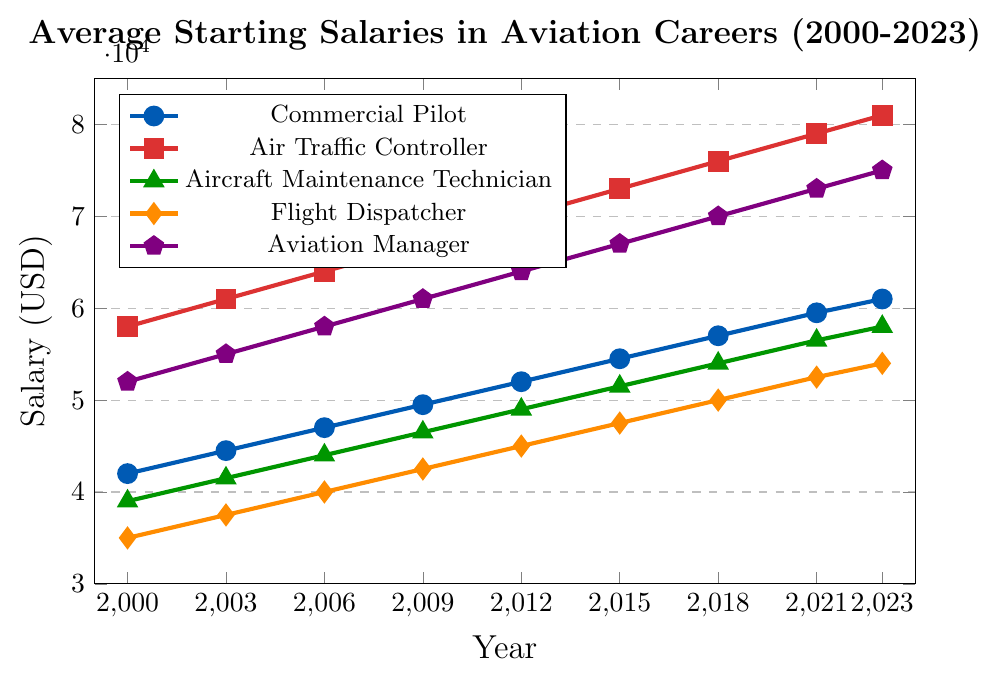What's the highest starting salary in 2023 and for which career? According to the chart, the highest starting salary in 2023 is represented by the highest point on the y-axis. The Air Traffic Controller line (shown in red) reaches $81,000, which is the highest value on the plot.
Answer: $81,000 for Air Traffic Controller What's the trend of the starting salary for Aircraft Maintenance Technicians from 2000 to 2023? The line for Aircraft Maintenance Technicians (in green) shows a steady upward trend from $39,000 in 2000 to $58,000 in 2023, indicating continuous growth over the years.
Answer: Steady upward trend from $39,000 to $58,000 In which year did the Commercial Pilot's salary surpass $50,000? Looking at the Commercial Pilot's line (in blue), it surpasses the $50,000 mark in 2012 when the salary reaches $52,000.
Answer: 2012 Compare the starting salary trends of Aviation Managers and Flight Dispatchers from 2000 to 2023. Which career has seen higher growth in starting salaries? The line for Aviation Managers (in purple) starts at $52,000 in 2000 and reaches $75,000 in 2023. The line for Flight Dispatchers (in orange) starts at $35,000 in 2000 and reaches $54,000 in 2023. The Aviation Manager's salary has grown by $23,000, whereas the Flight Dispatcher's salary has grown by $19,000. Hence, Aviation Managers have seen higher growth in starting salaries.
Answer: Aviation Managers What's the average starting salary for Commercial Pilots across all the years presented in the chart? To find the average starting salary for Commercial Pilots, sum the values: ($42,000 + $44,500 + $47,000 + $49,500 + $52,000 + $54,500 + $57,000 + $59,500 + $61,000) = $423,000. Then, divide by the number of years (9): $423,000 / 9 = $47,000.
Answer: $47,000 Which career had the lowest starting salary in 2000, and what was it? The lowest point on the chart for the year 2000 corresponds to Flight Dispatchers (in orange) with a starting salary of $35,000.
Answer: Flight Dispatchers, $35,000 What's the difference in starting salaries between Air Traffic Controllers and Aircraft Maintenance Technicians in 2023? The starting salary for Air Traffic Controllers in 2023 is $81,000, and for Aircraft Maintenance Technicians, it is $58,000. The difference is $81,000 - $58,000 = $23,000.
Answer: $23,000 How has the salary for Flight Dispatchers changed from 2015 to 2021? The starting salary for Flight Dispatchers in 2015 was $47,500, and in 2021 it was $52,500. The change is $52,500 - $47,500 = $5,000.
Answer: Increased by $5,000 